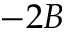Convert formula to latex. <formula><loc_0><loc_0><loc_500><loc_500>- 2 B</formula> 